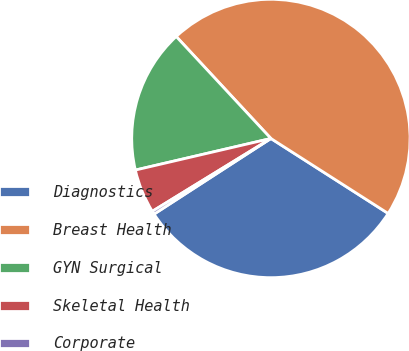<chart> <loc_0><loc_0><loc_500><loc_500><pie_chart><fcel>Diagnostics<fcel>Breast Health<fcel>GYN Surgical<fcel>Skeletal Health<fcel>Corporate<nl><fcel>31.8%<fcel>45.96%<fcel>16.73%<fcel>5.12%<fcel>0.38%<nl></chart> 